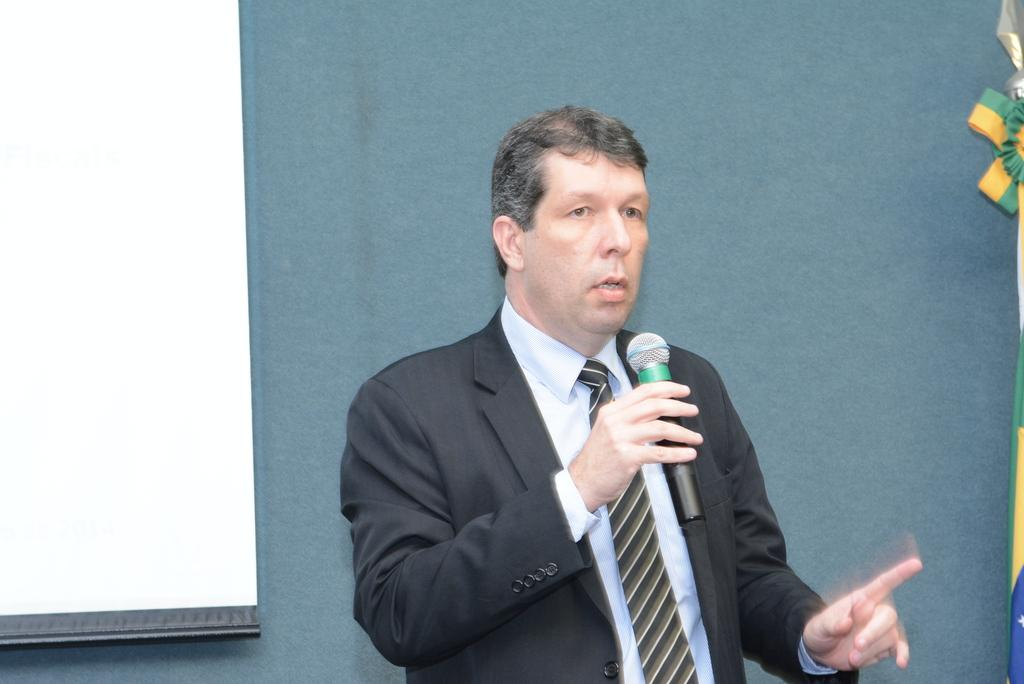What is the man in the image wearing? The man is wearing a blazer and a tie. What is the man holding in his hand? The man is holding a microphone in his hand. What is the man doing in the image? The man is talking. What can be seen in the background of the image? There is a wall and a screen in the background of the image. What type of stretch can be seen on the ground in the image? There is no stretch or ground visible in the image; it features a man talking with a microphone in his hand. What date is marked on the calendar in the image? There is no calendar present in the image. 